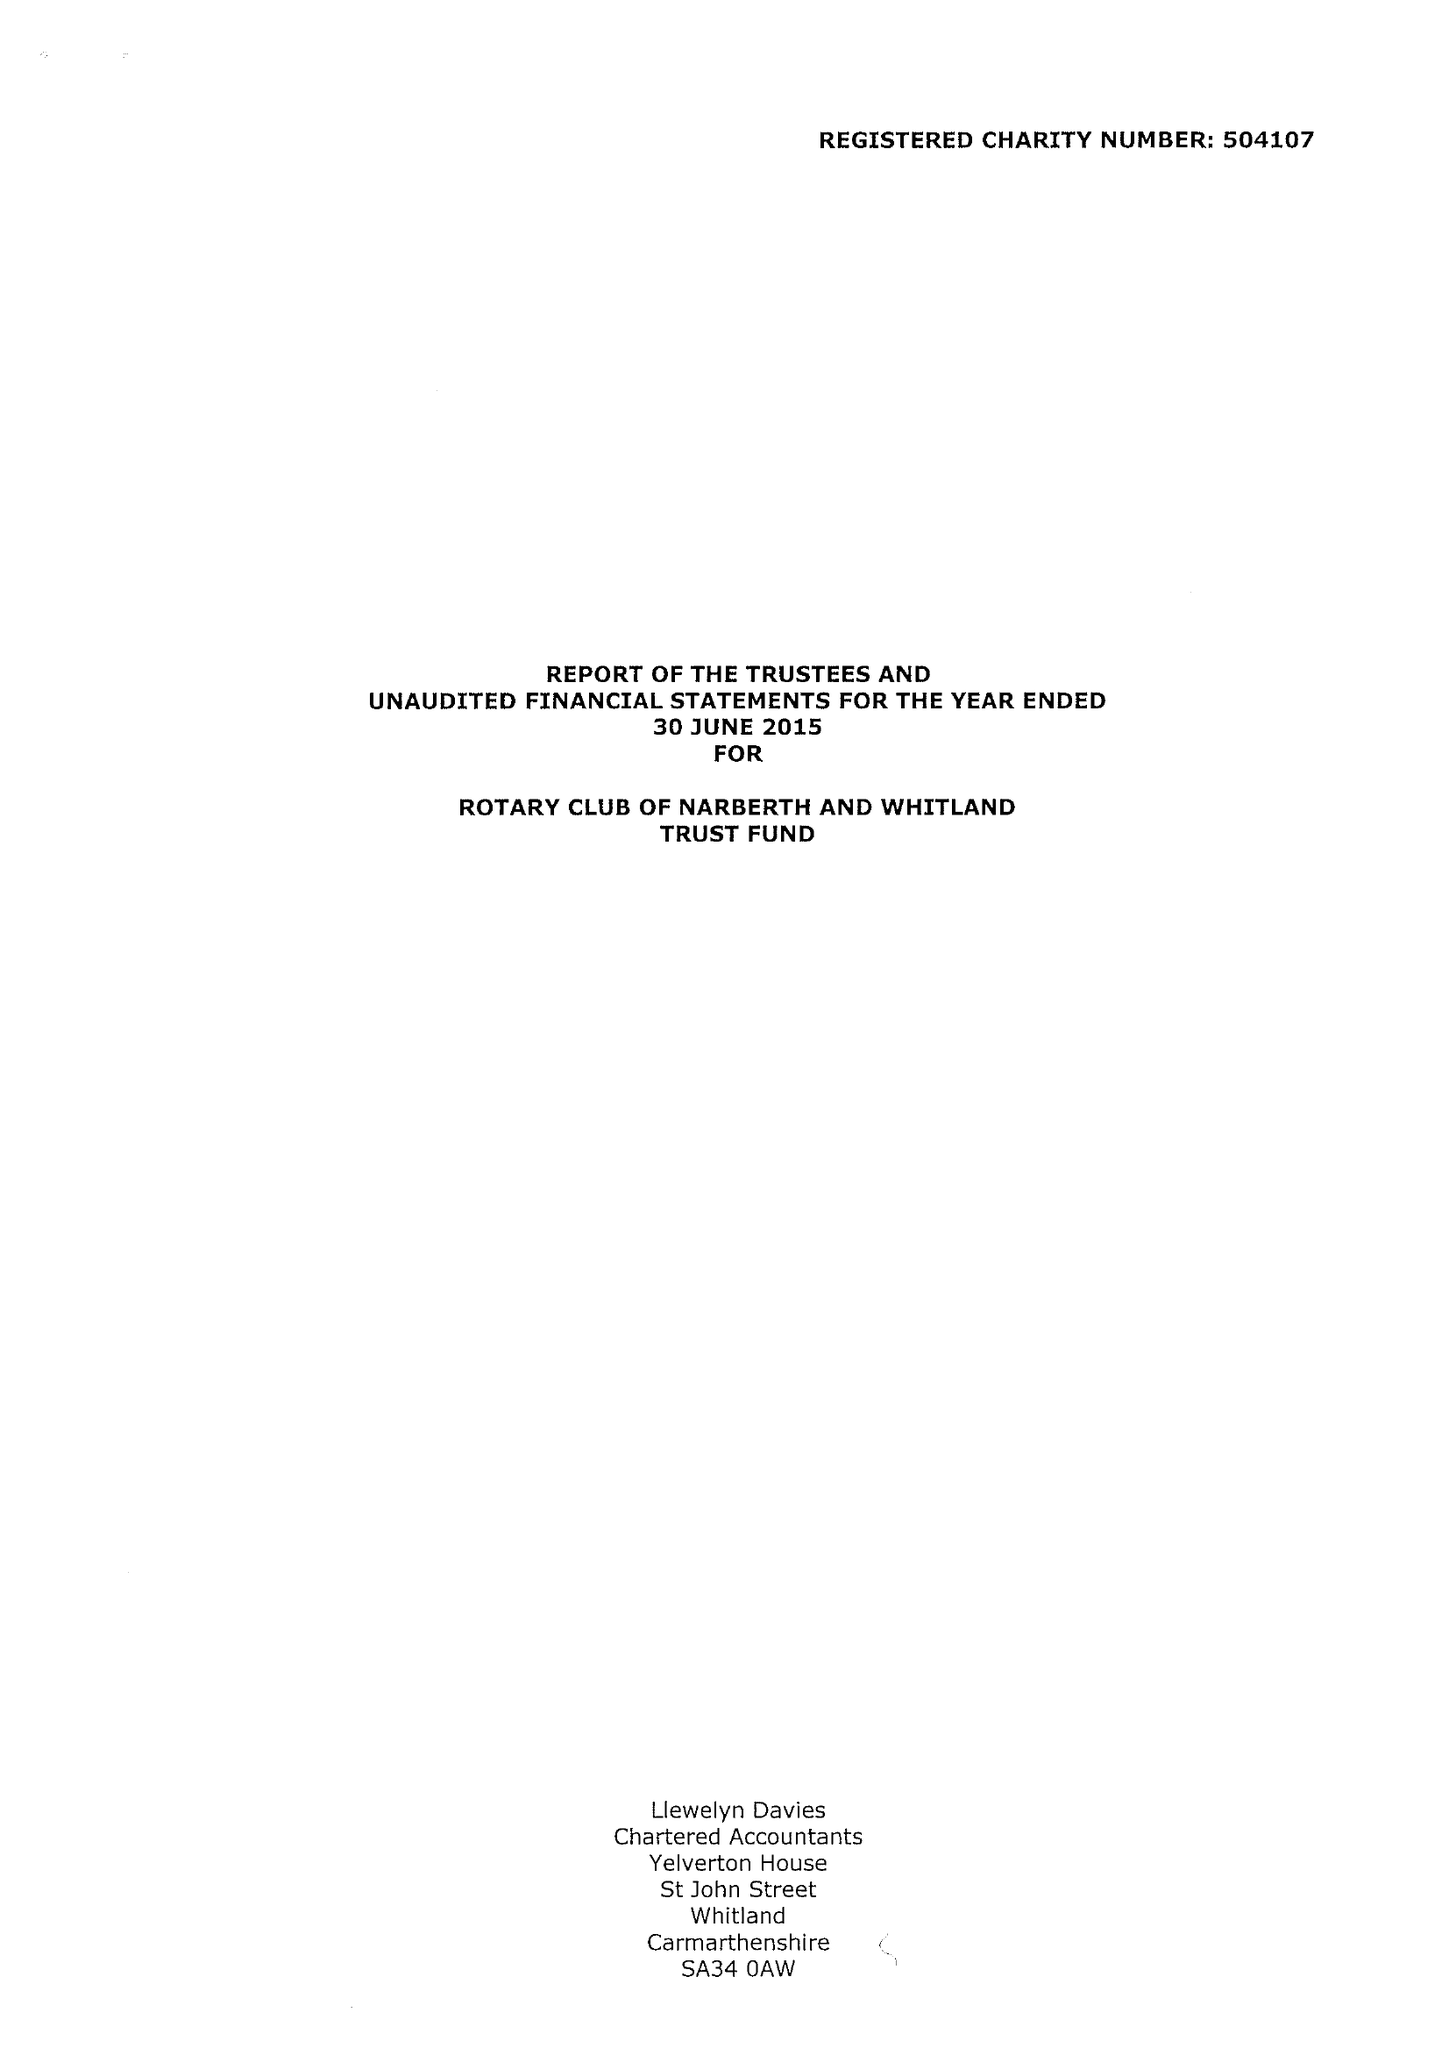What is the value for the address__street_line?
Answer the question using a single word or phrase. None 